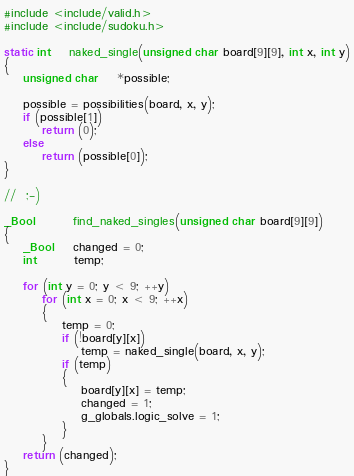Convert code to text. <code><loc_0><loc_0><loc_500><loc_500><_C_>#include <include/valid.h>
#include <include/sudoku.h>

static int	naked_single(unsigned char board[9][9], int x, int y)
{
	unsigned char	*possible;

	possible = possibilities(board, x, y);
	if (possible[1])
		return (0);
	else
		return (possible[0]);
}

//	;-)

_Bool		find_naked_singles(unsigned char board[9][9])
{
	_Bool	changed = 0;
	int		temp;
	
	for (int y = 0; y < 9; ++y)
		for (int x = 0; x < 9; ++x)
		{
			temp = 0;
			if (!board[y][x])
				temp = naked_single(board, x, y);
			if (temp)
			{
				board[y][x] = temp;
				changed = 1;
				g_globals.logic_solve = 1;
			}
		}
	return (changed);
}
</code> 